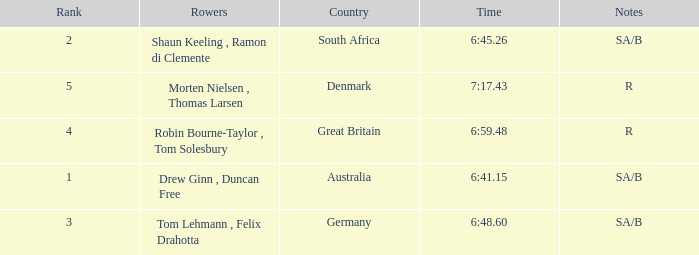What was the highest rank for rowers who represented Denmark? 5.0. 